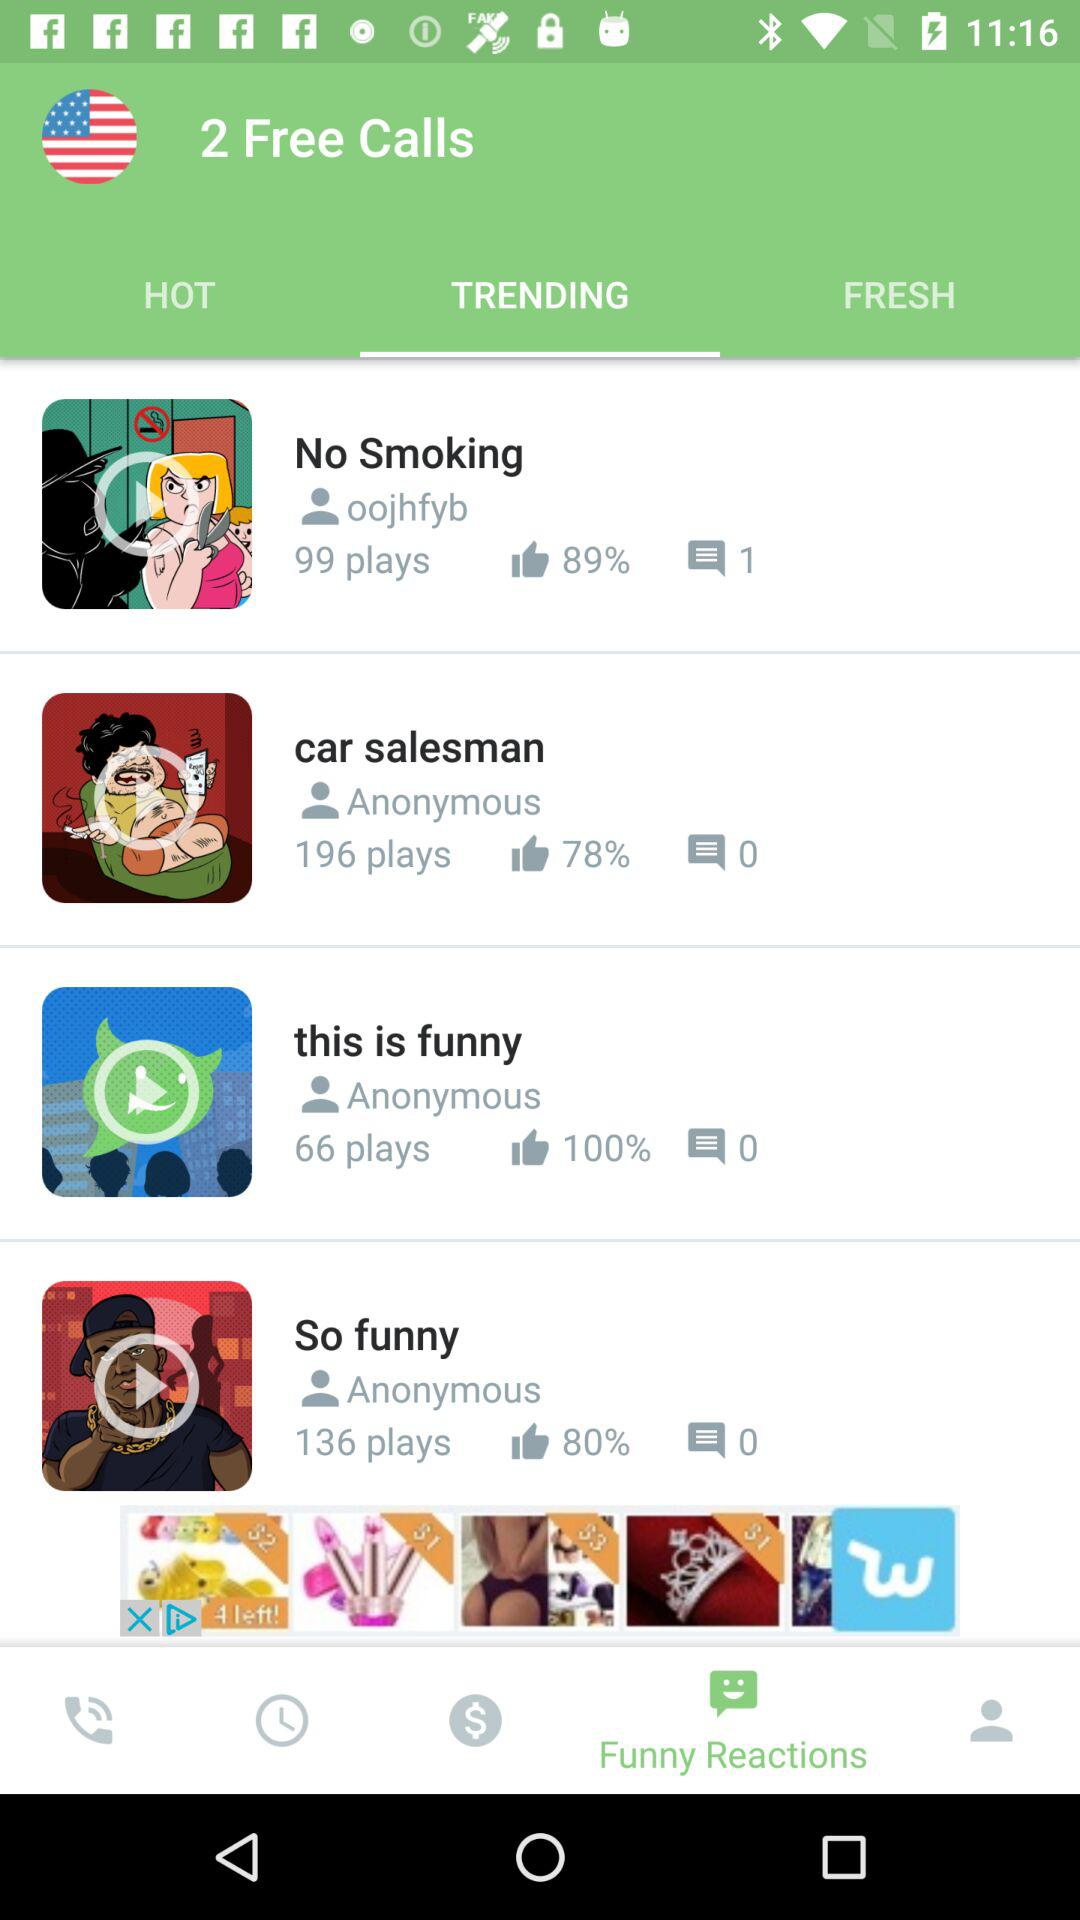What is the number of comments on the video "So funny"? There are zero comments on the video "So funny". 